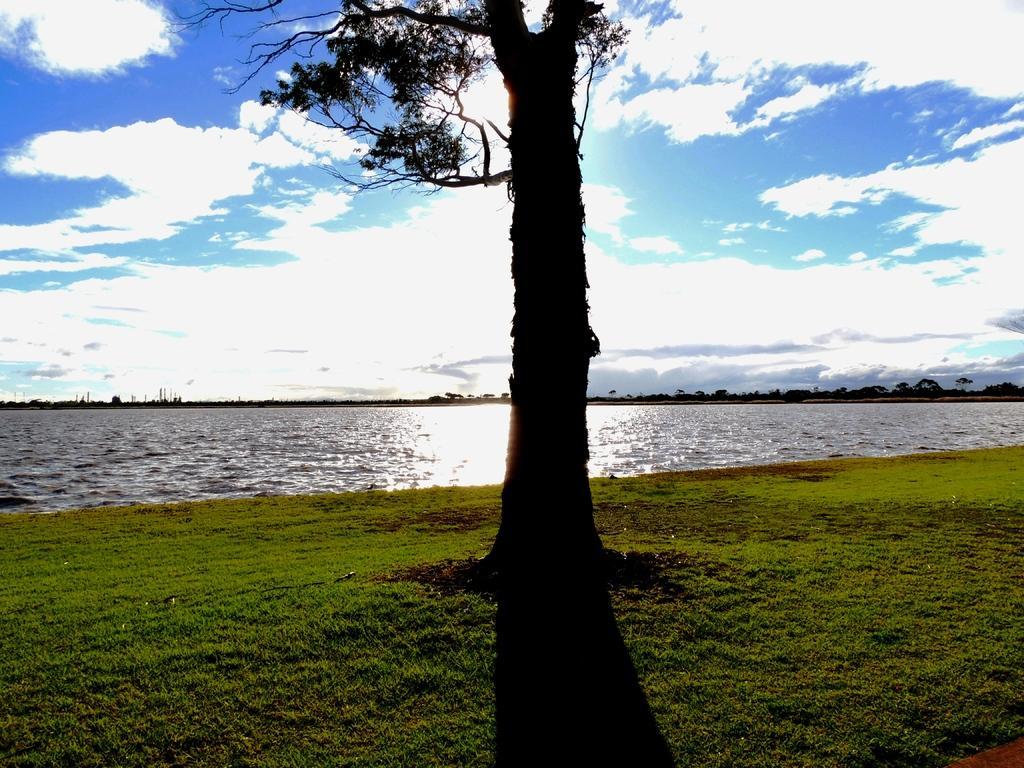How would you summarize this image in a sentence or two? There is a tree on a greenery ground and there is water beside it and there are trees in the background. 